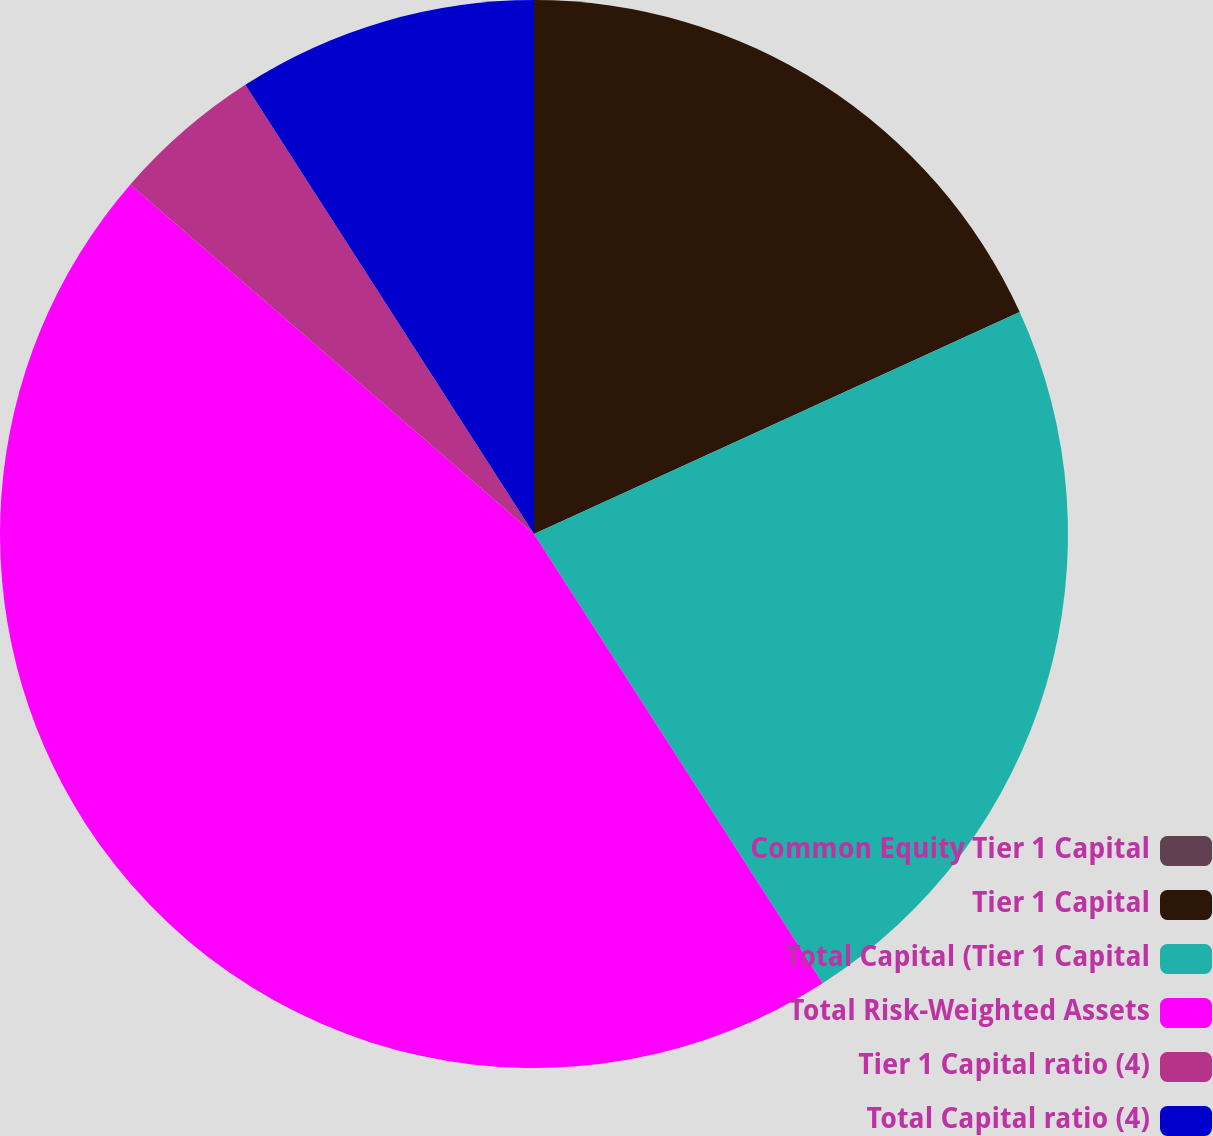Convert chart. <chart><loc_0><loc_0><loc_500><loc_500><pie_chart><fcel>Common Equity Tier 1 Capital<fcel>Tier 1 Capital<fcel>Total Capital (Tier 1 Capital<fcel>Total Risk-Weighted Assets<fcel>Tier 1 Capital ratio (4)<fcel>Total Capital ratio (4)<nl><fcel>0.0%<fcel>18.18%<fcel>22.73%<fcel>45.45%<fcel>4.55%<fcel>9.09%<nl></chart> 